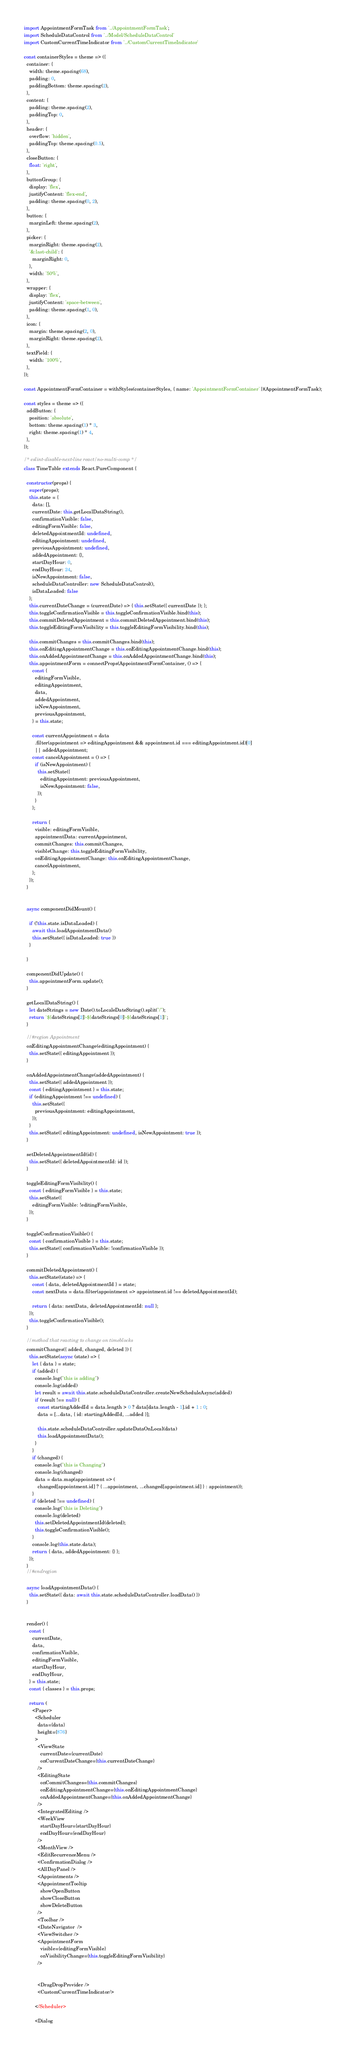Convert code to text. <code><loc_0><loc_0><loc_500><loc_500><_JavaScript_>import AppointmentFormTask from '../AppointmentFormTask';
import ScheduleDataControl from '../Model/ScheduleDataControl'
import CustomCurrentTimeIndicator from '../CustomCurrentTimeIndicator'

const containerStyles = theme => ({
  container: {
    width: theme.spacing(68),
    padding: 0,
    paddingBottom: theme.spacing(2),
  },
  content: {
    padding: theme.spacing(2),
    paddingTop: 0,
  },
  header: {
    overflow: 'hidden',
    paddingTop: theme.spacing(0.5),
  },
  closeButton: {
    float: 'right',
  },
  buttonGroup: {
    display: 'flex',
    justifyContent: 'flex-end',
    padding: theme.spacing(0, 2),
  },
  button: {
    marginLeft: theme.spacing(2),
  },
  picker: {
    marginRight: theme.spacing(2),
    '&:last-child': {
      marginRight: 0,
    },
    width: '50%',
  },
  wrapper: {
    display: 'flex',
    justifyContent: 'space-between',
    padding: theme.spacing(1, 0),
  },
  icon: {
    margin: theme.spacing(2, 0),
    marginRight: theme.spacing(2),
  },
  textField: {
    width: '100%',
  },
});

const AppointmentFormContainer = withStyles(containerStyles, { name: 'AppointmentFormContainer' })(AppointmentFormTask);

const styles = theme => ({
  addButton: {
    position: 'absolute',
    bottom: theme.spacing(1) * 3,
    right: theme.spacing(1) * 4,
  },
});

/* eslint-disable-next-line react/no-multi-comp */
class TimeTable extends React.PureComponent {

  constructor(props) {
    super(props);
    this.state = {
      data: [],
      currentDate: this.getLocalDataString(),
      confirmationVisible: false,
      editingFormVisible: false,
      deletedAppointmentId: undefined,
      editingAppointment: undefined,
      previousAppointment: undefined,
      addedAppointment: {},
      startDayHour: 0,
      endDayHour: 24,
      isNewAppointment: false,
      scheduleDataController: new ScheduleDataControl(),
      isDataLoaded: false
    };
    this.currentDateChange = (currentDate) => { this.setState({ currentDate }); };
    this.toggleConfirmationVisible = this.toggleConfirmationVisible.bind(this);
    this.commitDeletedAppointment = this.commitDeletedAppointment.bind(this);
    this.toggleEditingFormVisibility = this.toggleEditingFormVisibility.bind(this);

    this.commitChanges = this.commitChanges.bind(this);
    this.onEditingAppointmentChange = this.onEditingAppointmentChange.bind(this);
    this.onAddedAppointmentChange = this.onAddedAppointmentChange.bind(this);
    this.appointmentForm = connectProps(AppointmentFormContainer, () => {
      const {
        editingFormVisible,
        editingAppointment,
        data,
        addedAppointment,
        isNewAppointment,
        previousAppointment,
      } = this.state;

      const currentAppointment = data
        .filter(appointment => editingAppointment && appointment.id === editingAppointment.id)[0]
        || addedAppointment;
      const cancelAppointment = () => {
        if (isNewAppointment) {
          this.setState({
            editingAppointment: previousAppointment,
            isNewAppointment: false,
          });
        }
      };

      return {
        visible: editingFormVisible,
        appointmentData: currentAppointment,
        commitChanges: this.commitChanges,
        visibleChange: this.toggleEditingFormVisibility,
        onEditingAppointmentChange: this.onEditingAppointmentChange,
        cancelAppointment,
      };
    });
  }


  async componentDidMount() {

    if (!this.state.isDataLoaded) {
      await this.loadAppointmentData()
      this.setState({ isDataLoaded: true })
    }

  }

  componentDidUpdate() {
    this.appointmentForm.update();
  }

  getLocalDataString() {
    let dateStrings = new Date().toLocaleDateString().split("/");
    return `${dateStrings[2]}-${dateStrings[0]}-${dateStrings[1]}`;
  }

  //#region Appointment
  onEditingAppointmentChange(editingAppointment) {
    this.setState({ editingAppointment });
  }

  onAddedAppointmentChange(addedAppointment) {
    this.setState({ addedAppointment });
    const { editingAppointment } = this.state;
    if (editingAppointment !== undefined) {
      this.setState({
        previousAppointment: editingAppointment,
      });
    }
    this.setState({ editingAppointment: undefined, isNewAppointment: true });
  }

  setDeletedAppointmentId(id) {
    this.setState({ deletedAppointmentId: id });
  }

  toggleEditingFormVisibility() {
    const { editingFormVisible } = this.state;
    this.setState({
      editingFormVisible: !editingFormVisible,
    });
  }

  toggleConfirmationVisible() {
    const { confirmationVisible } = this.state;
    this.setState({ confirmationVisible: !confirmationVisible });
  }

  commitDeletedAppointment() {
    this.setState((state) => {
      const { data, deletedAppointmentId } = state;
      const nextData = data.filter(appointment => appointment.id !== deletedAppointmentId);

      return { data: nextData, deletedAppointmentId: null };
    });
    this.toggleConfirmationVisible();
  }

  //method that reacting to change on timeblocks 
  commitChanges({ added, changed, deleted }) {
    this.setState(async (state) => {
      let { data } = state;
      if (added) {
        console.log("this is adding")
        console.log(added)
        let result = await this.state.scheduleDataController.createNewScheduleAsync(added)
        if (result !== null) {
          const startingAddedId = data.length > 0 ? data[data.length - 1].id + 1 : 0;
          data = [...data, { id: startingAddedId, ...added }];

          this.state.scheduleDataController.updateDataOnLocal(data)
          this.loadAppointmentData();
        }
      }
      if (changed) {
        console.log("this is Changing")
        console.log(changed)
        data = data.map(appointment => (
          changed[appointment.id] ? { ...appointment, ...changed[appointment.id] } : appointment));
      }
      if (deleted !== undefined) {
        console.log("this is Deleting")
        console.log(deleted)
        this.setDeletedAppointmentId(deleted);
        this.toggleConfirmationVisible();
      }
      console.log(this.state.data);
      return { data, addedAppointment: {} };
    });
  }
  //#endregion

  async loadAppointmentData() {
    this.setState({ data: await this.state.scheduleDataController.loadData() })
  }


  render() {
    const {
      currentDate,
      data,
      confirmationVisible,
      editingFormVisible,
      startDayHour,
      endDayHour,
    } = this.state;
    const { classes } = this.props;

    return (
      <Paper>
        <Scheduler
          data={data}
          height={876}
        >
          <ViewState
            currentDate={currentDate}
            onCurrentDateChange={this.currentDateChange}
          />
          <EditingState
            onCommitChanges={this.commitChanges}
            onEditingAppointmentChange={this.onEditingAppointmentChange}
            onAddedAppointmentChange={this.onAddedAppointmentChange}
          />
          <IntegratedEditing />
          <WeekView
            startDayHour={startDayHour}
            endDayHour={endDayHour}
          />
          <MonthView />
          <EditRecurrenceMenu />
          <ConfirmationDialog />
          <AllDayPanel />
          <Appointments />
          <AppointmentTooltip
            showOpenButton
            showCloseButton
            showDeleteButton
          />
          <Toolbar />
          <DateNavigator  />
          <ViewSwitcher />
          <AppointmentForm
            visible={editingFormVisible}
            onVisibilityChange={this.toggleEditingFormVisibility}
          />


          <DragDropProvider />
          <CustomCurrentTimeIndicator/>

        </Scheduler>

        <Dialog</code> 